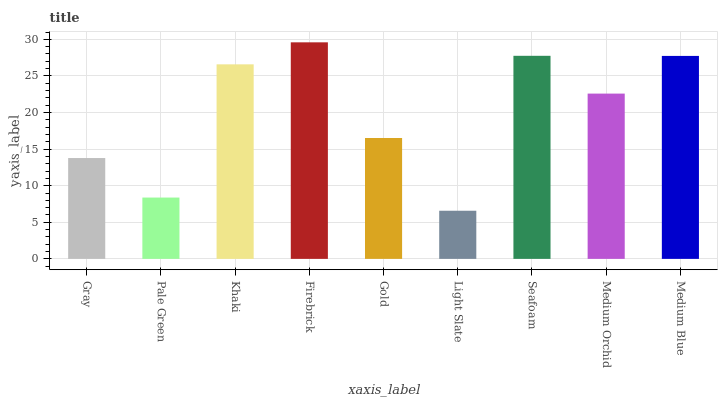Is Light Slate the minimum?
Answer yes or no. Yes. Is Firebrick the maximum?
Answer yes or no. Yes. Is Pale Green the minimum?
Answer yes or no. No. Is Pale Green the maximum?
Answer yes or no. No. Is Gray greater than Pale Green?
Answer yes or no. Yes. Is Pale Green less than Gray?
Answer yes or no. Yes. Is Pale Green greater than Gray?
Answer yes or no. No. Is Gray less than Pale Green?
Answer yes or no. No. Is Medium Orchid the high median?
Answer yes or no. Yes. Is Medium Orchid the low median?
Answer yes or no. Yes. Is Khaki the high median?
Answer yes or no. No. Is Gold the low median?
Answer yes or no. No. 